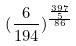Convert formula to latex. <formula><loc_0><loc_0><loc_500><loc_500>( \frac { 6 } { 1 9 4 } ) ^ { \frac { \frac { 3 9 7 } { 5 } } { 8 6 } }</formula> 